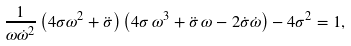Convert formula to latex. <formula><loc_0><loc_0><loc_500><loc_500>\frac { 1 } { \omega \dot { \omega } ^ { 2 } } \left ( 4 \sigma \omega ^ { 2 } + { \ddot { \sigma } } \right ) \left ( 4 \sigma \, \omega ^ { 3 } + { \ddot { \sigma } } \, \omega - 2 { \dot { \sigma } } \dot { \omega } \right ) - 4 \sigma ^ { 2 } = 1 ,</formula> 